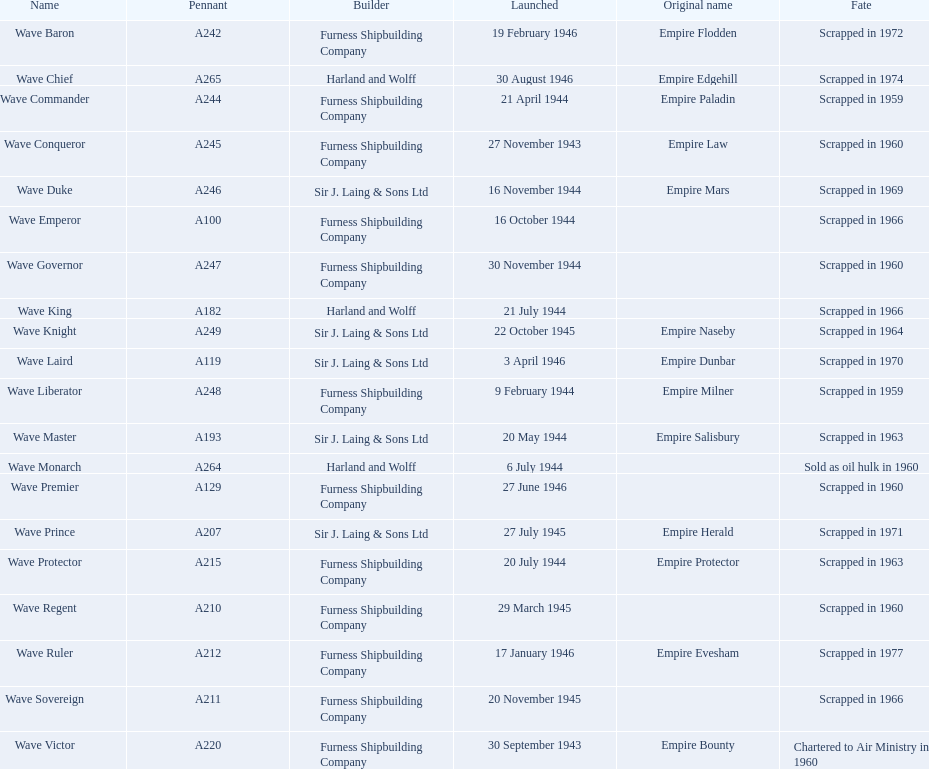What builders launched ships in november of any year? Furness Shipbuilding Company, Sir J. Laing & Sons Ltd, Furness Shipbuilding Company, Furness Shipbuilding Company. What ship builders ships had their original name's changed prior to scrapping? Furness Shipbuilding Company, Sir J. Laing & Sons Ltd. What was the name of the ship that was built in november and had its name changed prior to scrapping only 12 years after its launch? Wave Conqueror. 